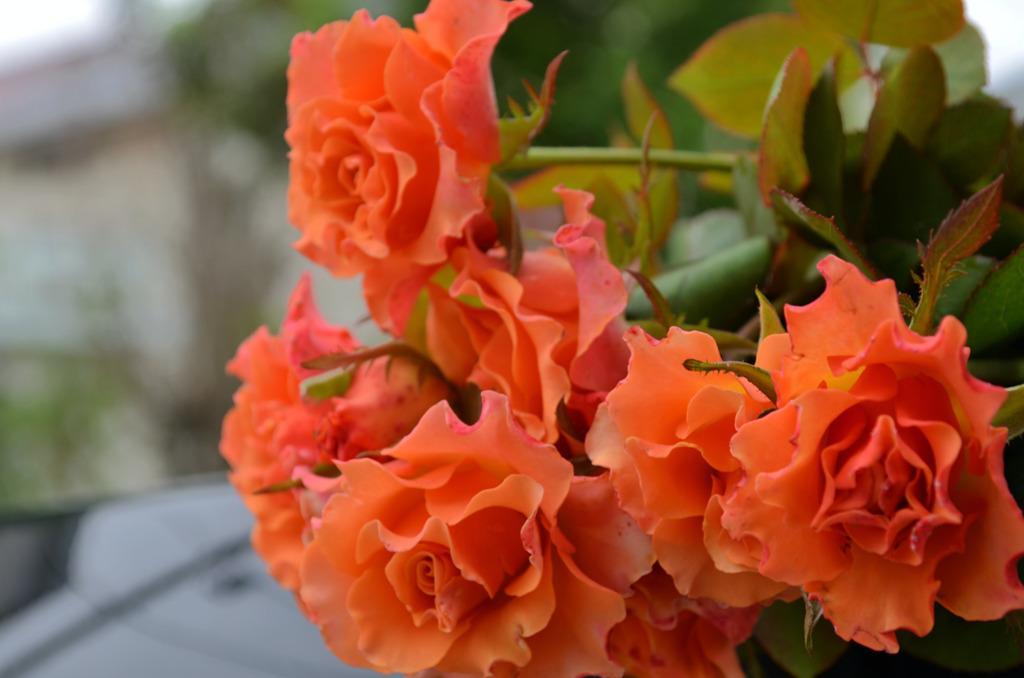Please provide a concise description of this image. In this picture there are orange color flowers on the plant. At the back the image is blurry. 